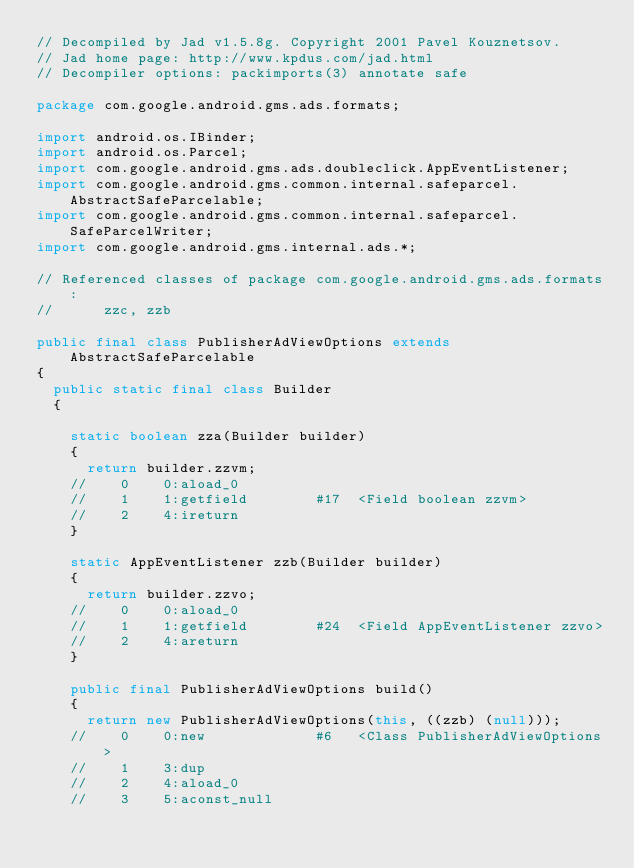Convert code to text. <code><loc_0><loc_0><loc_500><loc_500><_Java_>// Decompiled by Jad v1.5.8g. Copyright 2001 Pavel Kouznetsov.
// Jad home page: http://www.kpdus.com/jad.html
// Decompiler options: packimports(3) annotate safe 

package com.google.android.gms.ads.formats;

import android.os.IBinder;
import android.os.Parcel;
import com.google.android.gms.ads.doubleclick.AppEventListener;
import com.google.android.gms.common.internal.safeparcel.AbstractSafeParcelable;
import com.google.android.gms.common.internal.safeparcel.SafeParcelWriter;
import com.google.android.gms.internal.ads.*;

// Referenced classes of package com.google.android.gms.ads.formats:
//			zzc, zzb

public final class PublisherAdViewOptions extends AbstractSafeParcelable
{
	public static final class Builder
	{

		static boolean zza(Builder builder)
		{
			return builder.zzvm;
		//    0    0:aload_0         
		//    1    1:getfield        #17  <Field boolean zzvm>
		//    2    4:ireturn         
		}

		static AppEventListener zzb(Builder builder)
		{
			return builder.zzvo;
		//    0    0:aload_0         
		//    1    1:getfield        #24  <Field AppEventListener zzvo>
		//    2    4:areturn         
		}

		public final PublisherAdViewOptions build()
		{
			return new PublisherAdViewOptions(this, ((zzb) (null)));
		//    0    0:new             #6   <Class PublisherAdViewOptions>
		//    1    3:dup             
		//    2    4:aload_0         
		//    3    5:aconst_null     </code> 